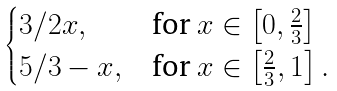<formula> <loc_0><loc_0><loc_500><loc_500>\begin{cases} 3 / 2 x , & \text {for} \ x \in \left [ 0 , \frac { 2 } { 3 } \right ] \\ 5 / 3 - x , & \text {for} \ x \in \left [ \frac { 2 } { 3 } , 1 \right ] . \end{cases}</formula> 